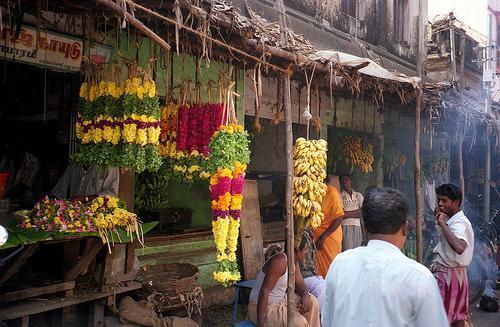How many people are visible?
Give a very brief answer. 7. 